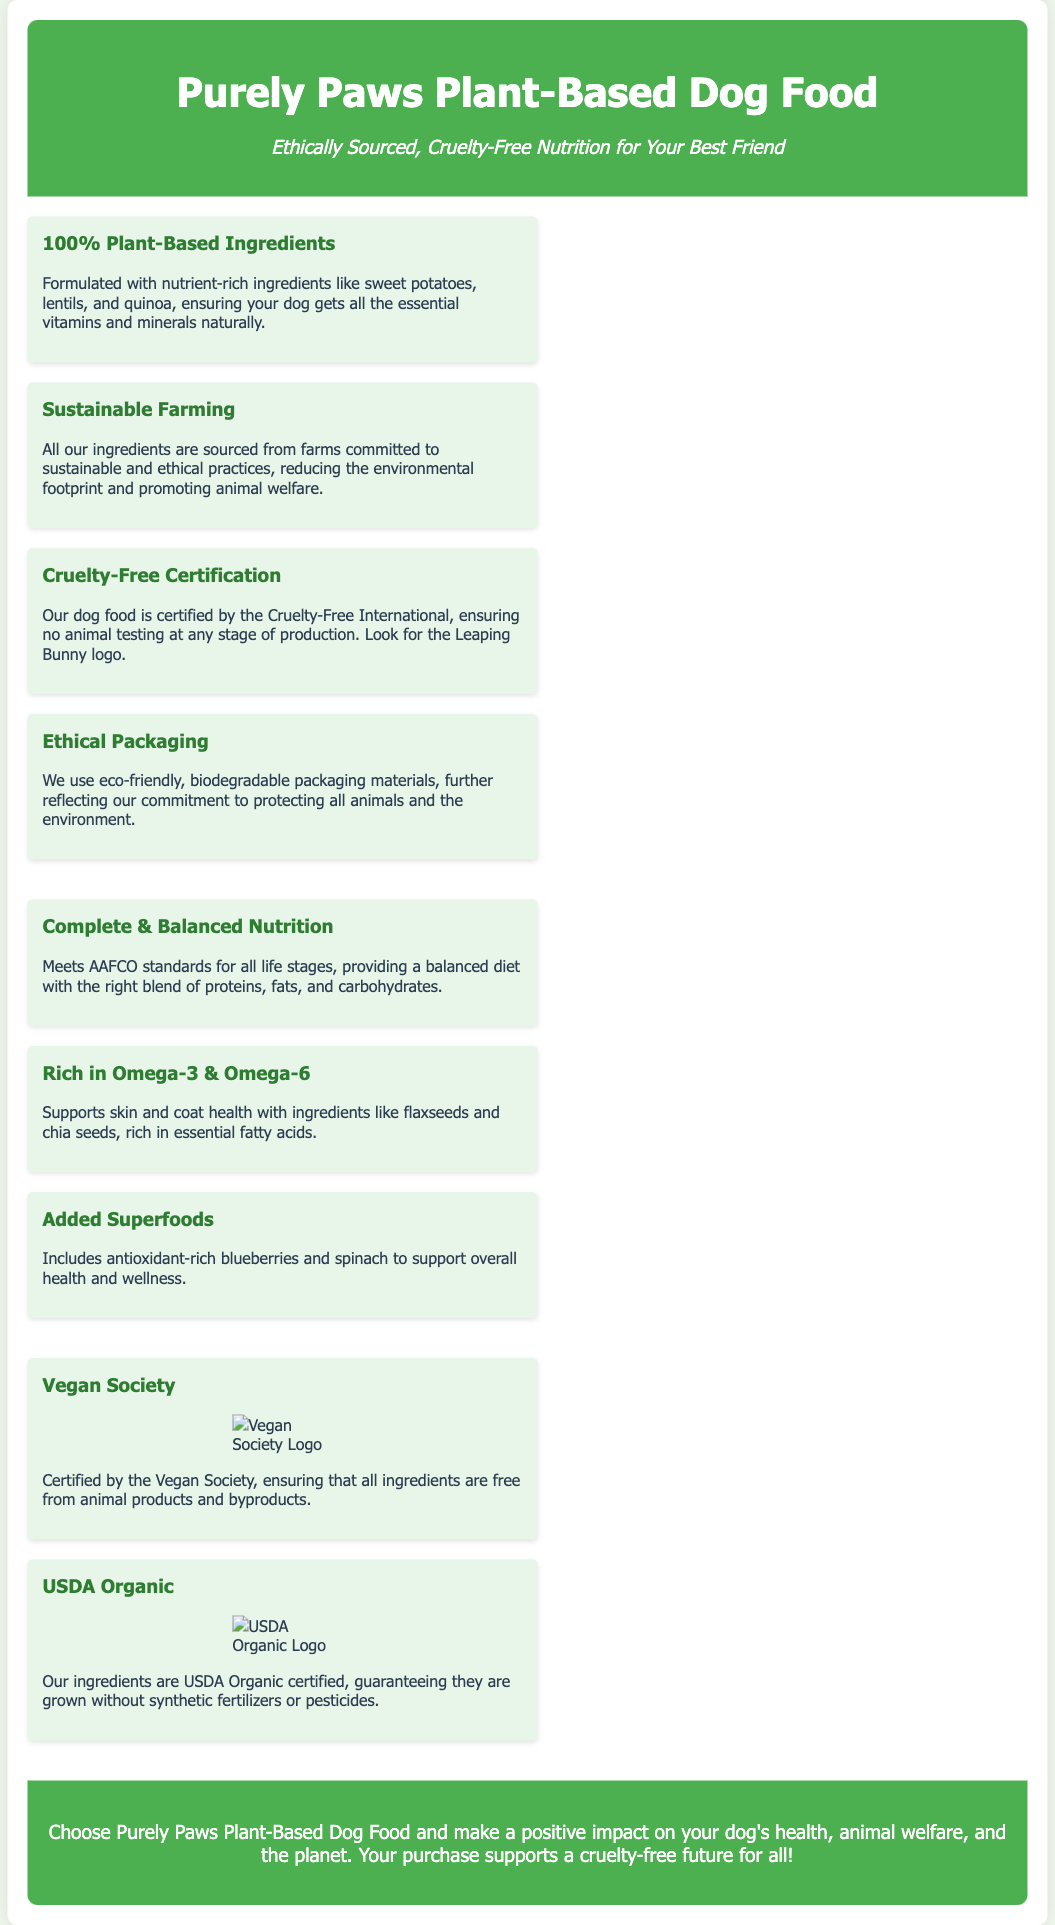what is the main ingredient type in Purely Paws Dog Food? The main ingredient type is stated clearly in the product title and feature sections of the document as plant-based.
Answer: Plant-Based which certification ensures that no animal testing is involved in production? The document states the Cruelty-Free certification guarantees no animal testing at any stage of production.
Answer: Cruelty-Free Certification what logo should you look for to ensure the product is cruelty-free? The document mentions the Leaping Bunny logo as the indicator of cruelty-free certification.
Answer: Leaping Bunny logo what are two types of fatty acids included in the dog food? The nutrition section lists Omega-3 and Omega-6 as the two types of fatty acids.
Answer: Omega-3 & Omega-6 what is the primary purpose of ethical packaging mentioned in the document? The document emphasizes that ethical packaging reflects a commitment to protecting all animals and the environment.
Answer: Protecting animals and environment which organization certifies that all ingredients are free from animal products? The Vegan Society certifies that all ingredients are free from animal products as stated in the certifications section.
Answer: Vegan Society what type of farming is emphasized for ingredient sourcing? The document highlights sustainable farming practices as crucial for sourcing ingredients.
Answer: Sustainable Farming what type of ingredients support overall health and wellness in the dog food? Antioxidant-rich ingredients like blueberries and spinach are highlighted in the nutrition section for supporting overall health.
Answer: Blueberries and Spinach 